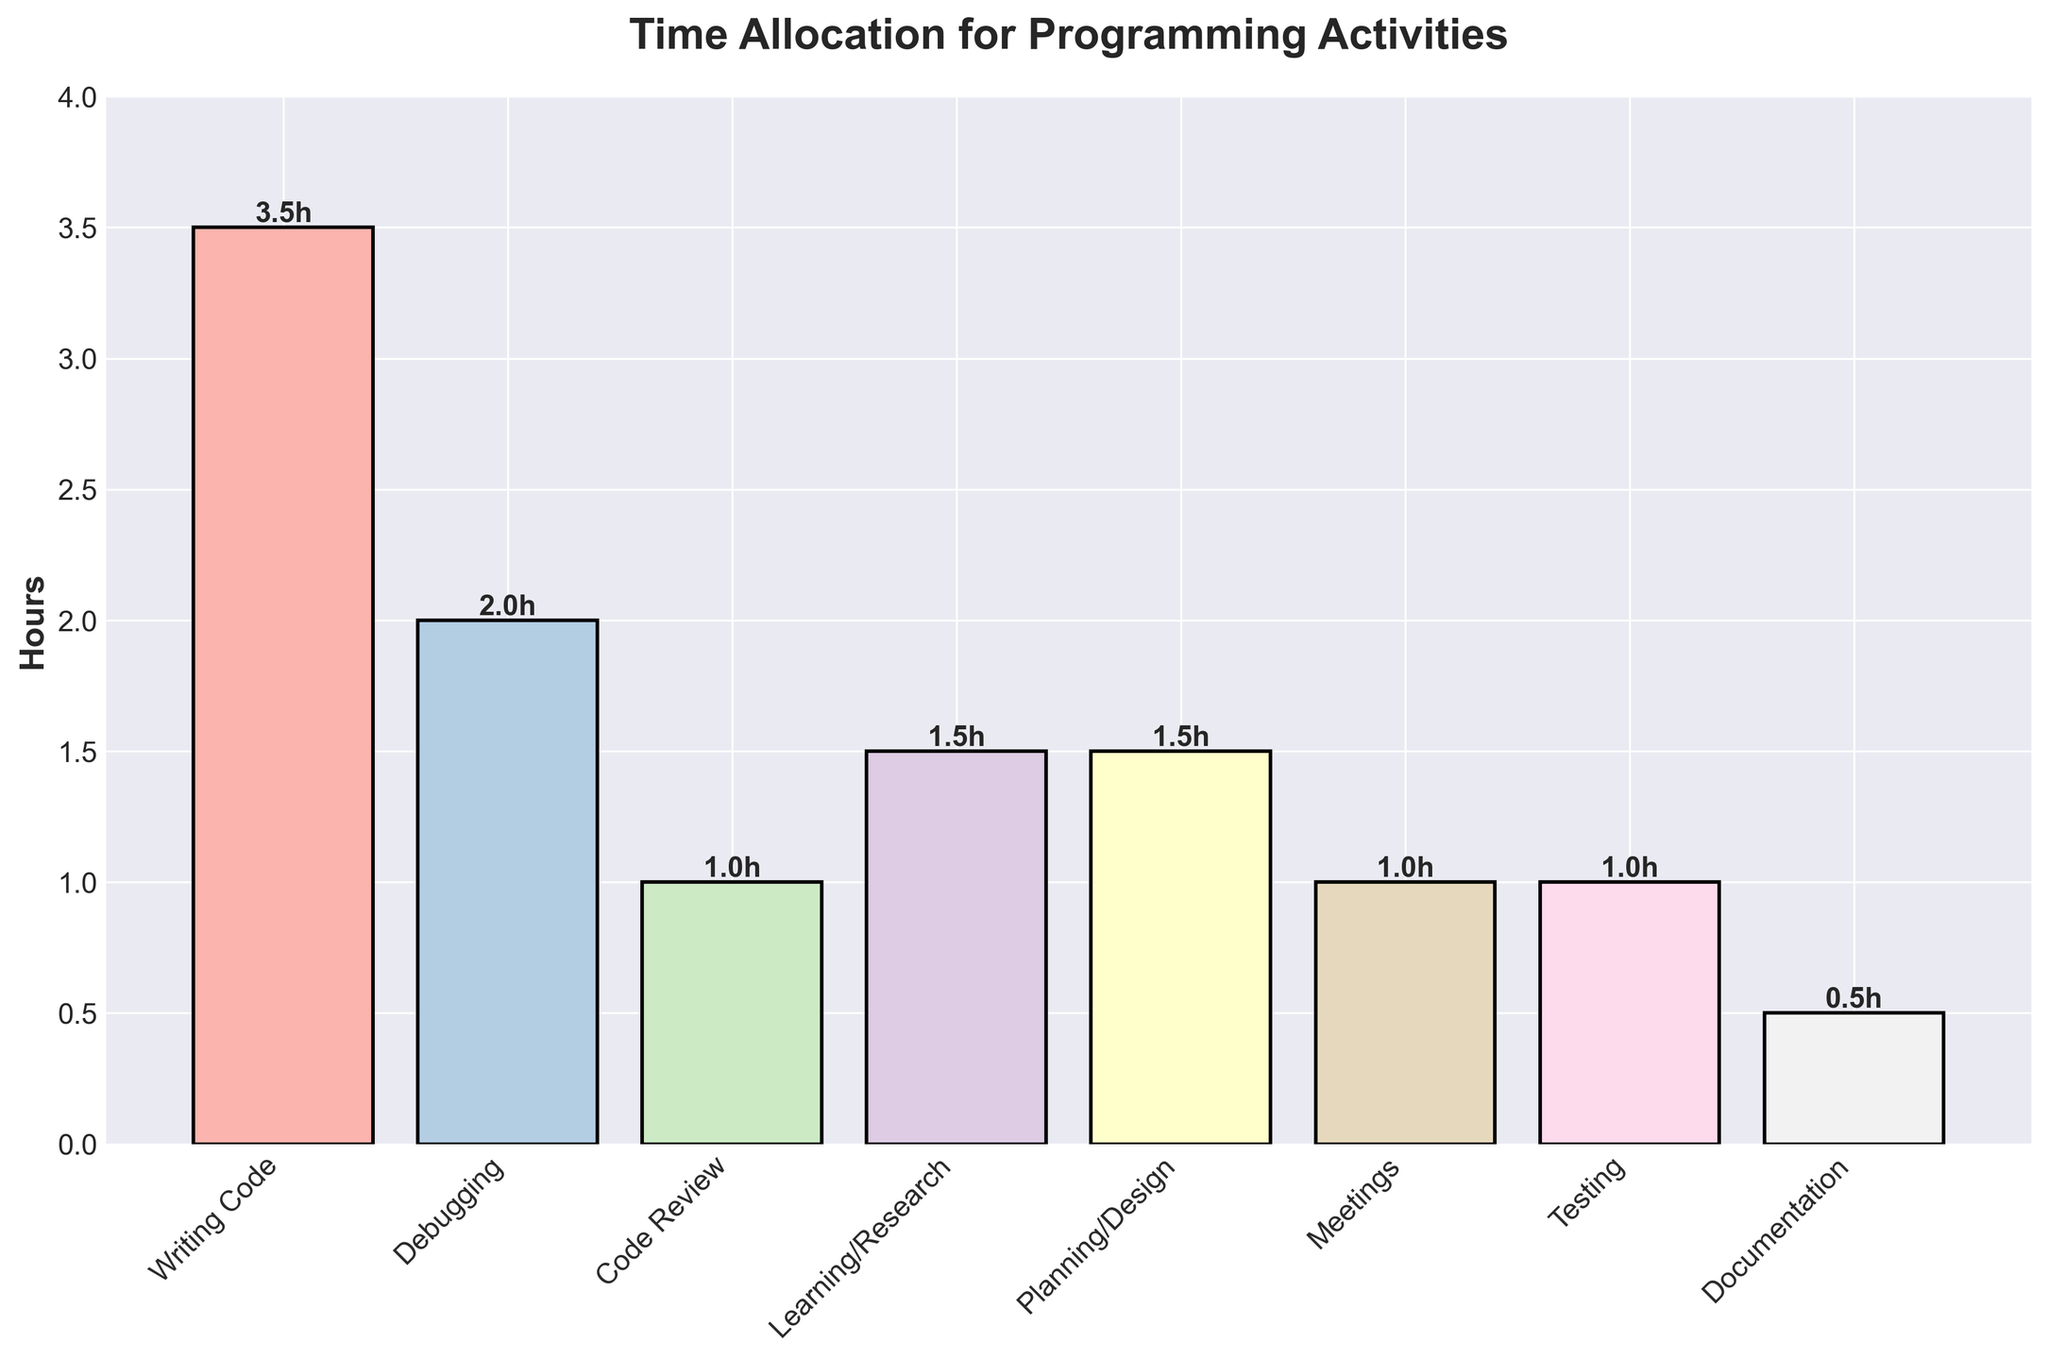What's the total number of hours spent on Learning/Research and Planning/Design combined? Add the hours for Learning/Research (1.5 hours) and Planning/Design (1.5 hours): 1.5 + 1.5 = 3 hours
Answer: 3 hours Which activity takes the largest portion of time? Identify the bar with the greatest height, which corresponds to Writing Code at 3.5 hours
Answer: Writing Code How many more hours are spent on Writing Code compared to Testing? Subtract the hours for Testing (1 hour) from the hours for Writing Code (3.5 hours): 3.5 - 1 = 2.5 hours
Answer: 2.5 hours Is the time spent on Debugging greater than or equal to the time spent on Meetings? Compare the hours for Debugging (2 hours) to the hours for Meetings (1 hour). Debugging is greater than Meetings
Answer: Yes What's the average amount of time spent on Documentation and Code Review? Add the hours for Documentation (0.5 hours) and Code Review (1 hour), then divide by 2: (0.5 + 1) / 2 = 0.75 hours
Answer: 0.75 hours Between Learning/Research and Code Review, which activity is allocated more time, and by how much? Compare the hours for Learning/Research (1.5 hours) to the hours for Code Review (1 hour). Learning/Research is greater. Subtract the smaller value from the larger one: 1.5 - 1 = 0.5 hours
Answer: Learning/Research by 0.5 hours What is the combined total time spent on Meetings, Testing, and Documentation? Add the hours for Meetings (1 hour), Testing (1 hour), and Documentation (0.5 hours): 1 + 1 + 0.5 = 2.5 hours
Answer: 2.5 hours Are there any activities that have equal time allocation? If yes, which ones? Identify the activities with the same height for their bars. Learning/Research and Planning/Design both have 1.5 hours
Answer: Yes, Learning/Research and Planning/Design Calculate the difference in time spent on Planning/Design versus Documentation. Subtract the hours for Documentation (0.5 hours) from the hours for Planning/Design (1.5 hours): 1.5 - 0.5 = 1 hour
Answer: 1 hour How does the time spent on Code Review compare to the time on debugging? Compare the heights of bars for Code Review (1 hour) and Debugging (2 hours). Debugging has more hours
Answer: Debugging has more hours 